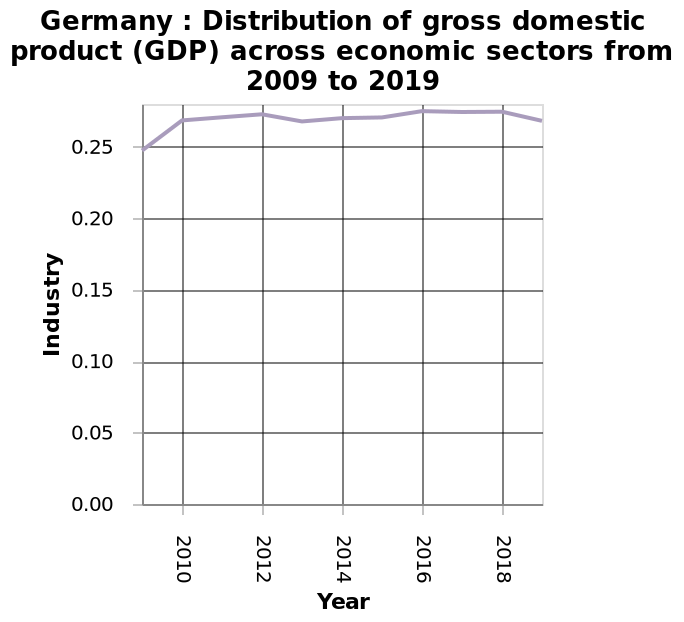<image>
What does the line chart depict? The line chart depicts the distribution of gross domestic product (GDP) across economic sectors in Germany from 2009 to 2019. How is the industry shown on the line chart? The industry is shown as a linear scale. Is there a specific year mentioned when the industry started remaining above 0.25? Yes, the year mentioned is 2010 when the industry started remaining above 0.25. Offer a thorough analysis of the image. The chart shows that from 2010, industry remained above 0.25. Does the line chart inaccurately present the distribution of gross domestic product (GDP) across economic sectors in Germany from 2009 to 2019? No.The line chart depicts the distribution of gross domestic product (GDP) across economic sectors in Germany from 2009 to 2019. 